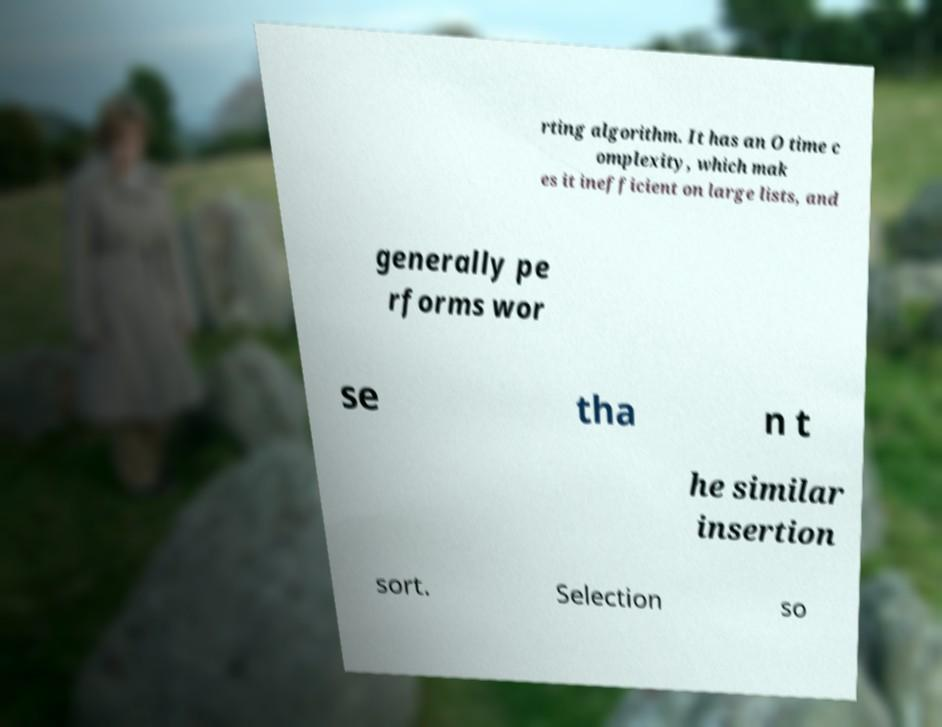What messages or text are displayed in this image? I need them in a readable, typed format. rting algorithm. It has an O time c omplexity, which mak es it inefficient on large lists, and generally pe rforms wor se tha n t he similar insertion sort. Selection so 